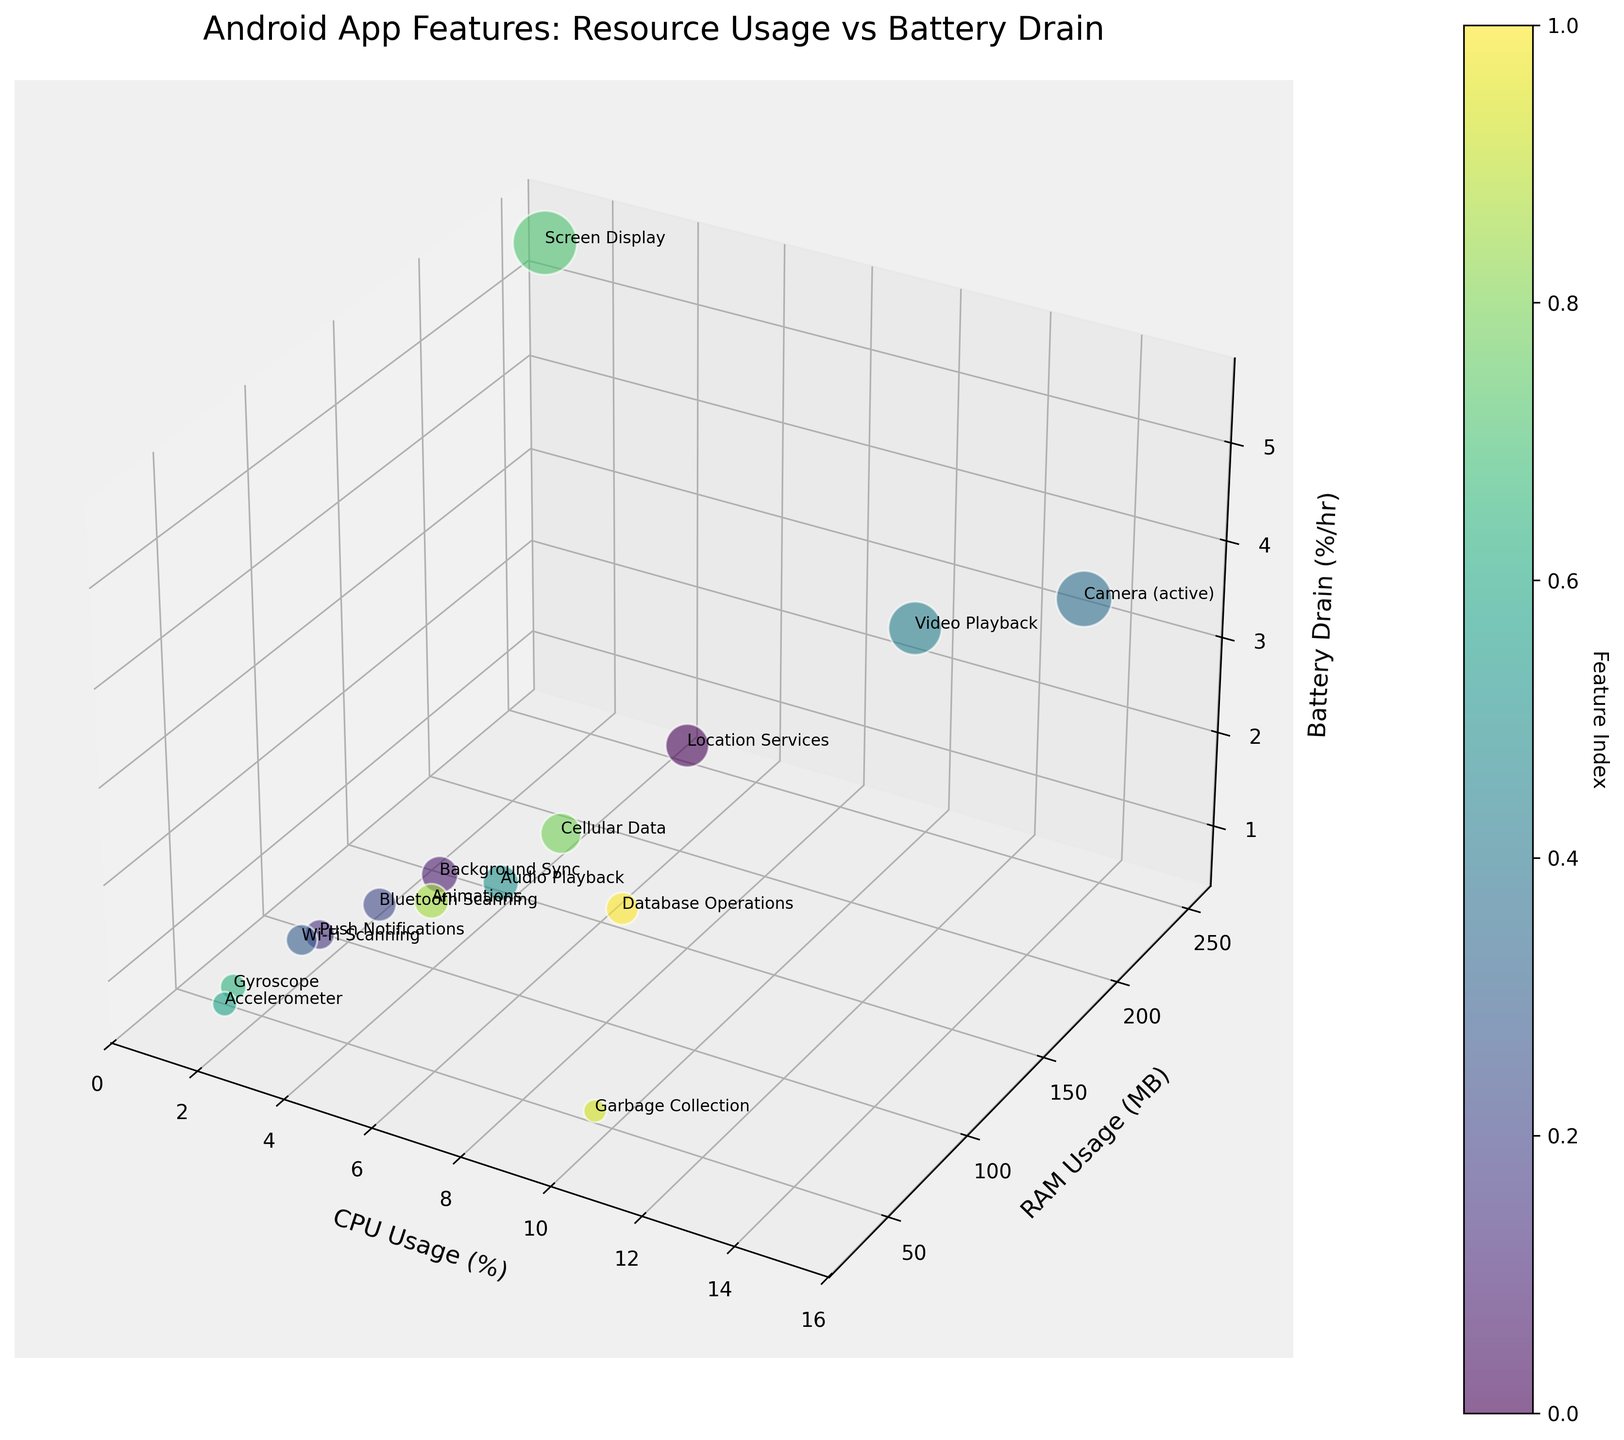What is the title of the 3D bubble chart? The title of the chart is typically at the top and summarizes the data representation. It helps understand the focus of the visualization.
Answer: Android App Features: Resource Usage vs Battery Drain What are the labels of the three axes on the chart? The axis labels describe what each axis represents in the chart. The X-axis represents CPU Usage (%), the Y-axis represents RAM Usage (MB), and the Z-axis represents Battery Drain (%/hr).
Answer: CPU Usage (%), RAM Usage (MB), Battery Drain (%/hr) Which feature has the highest battery drain? By examining the Z-axis or highest point along it, you can identify which feature is at that peak.
Answer: Screen Display Compare the CPU usage of "Camera (active)" and "Database Operations." Which one uses more CPU? Locate the data points for both features and compare their positions along the X-axis. "Camera (active)" is further along the X-axis than "Database Operations," indicating higher CPU usage.
Answer: Camera (active) How does the RAM usage of "Video Playback" compare to "Background Sync"? Locate both features along the Y-axis and compare their positions. "Video Playback" has a higher RAM usage, shown by a position further up the Y-axis.
Answer: Video Playback uses more RAM What is the average battery drain for features with a CPU usage of 5%? Identify features with a CPU usage of 5%, then calculate the average of their battery drain values along the Z-axis. Here, "Background Sync" and "Animations" have a CPU usage of 5%. Their battery drain values are 1.8%/hr and 1.6%/hr, respectively. The average is (1.8 + 1.6) / 2 = 1.7.
Answer: 1.7 Which feature has the lowest CPU usage but a noticeable battery drain? Look for the features close to the origin along the X-axis (low CPU usage) but higher along the Z-axis (battery drain). "Screen Display" has the lowest CPU usage (1%) but the highest battery drain (5.5%/hr).
Answer: Screen Display What is the total RAM usage of "Push Notifications" and "Bluetooth Scanning"? Find the positions of both features along the Y-axis and sum their values. "Push Notifications" has 60 MB and "Bluetooth Scanning" has 70 MB. 60 + 70 = 130 MB.
Answer: 130 MB Which feature's bubble size is significantly larger, indicating higher battery drain, "Accelerometer" or "Video Playback"? Compare the sizes of the bubbles representing both features. The bubble for "Video Playback" is significantly larger, indicating a higher battery drain.
Answer: Video Playback 